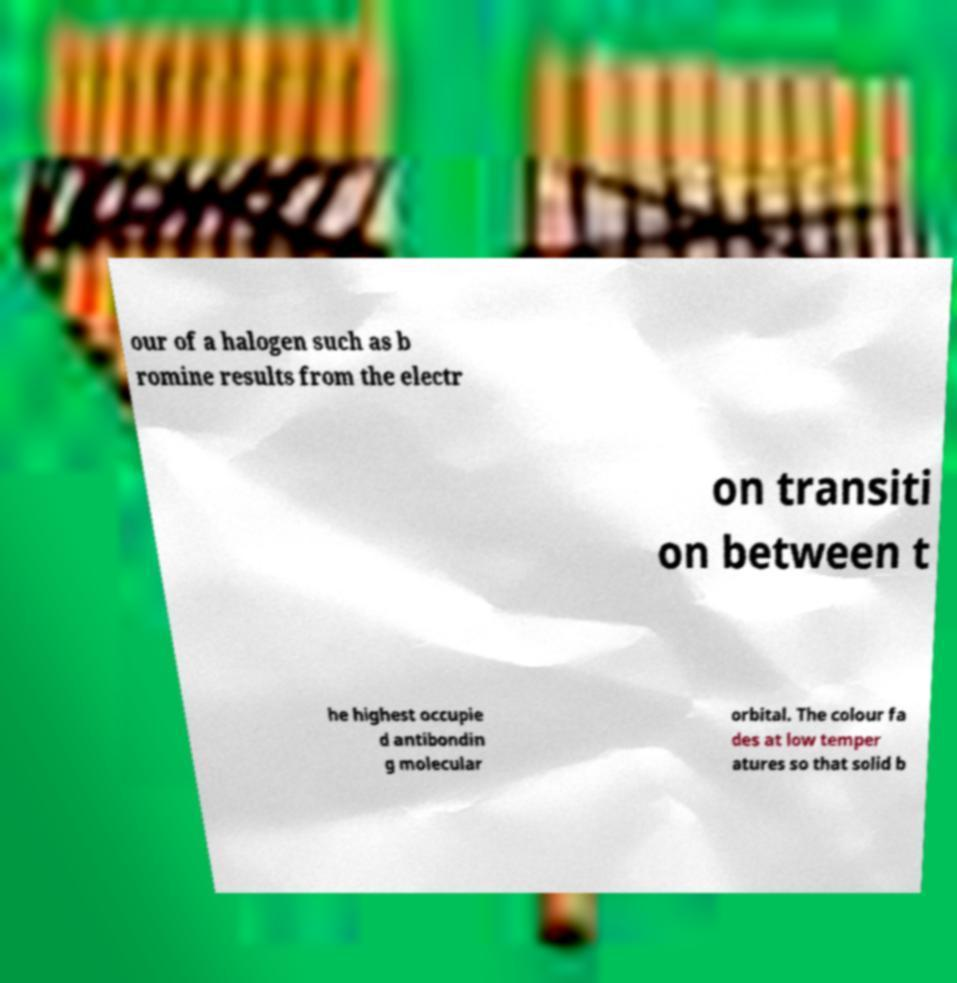Could you extract and type out the text from this image? our of a halogen such as b romine results from the electr on transiti on between t he highest occupie d antibondin g molecular orbital. The colour fa des at low temper atures so that solid b 